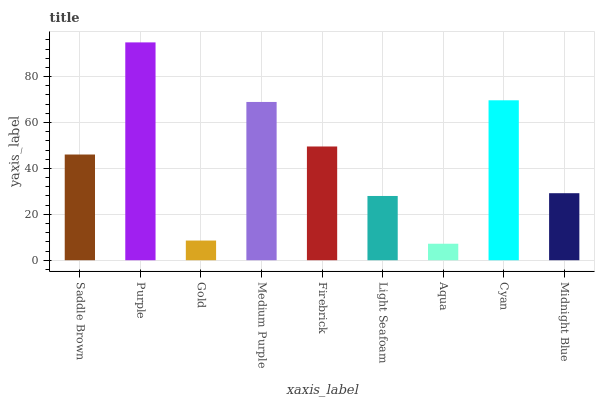Is Aqua the minimum?
Answer yes or no. Yes. Is Purple the maximum?
Answer yes or no. Yes. Is Gold the minimum?
Answer yes or no. No. Is Gold the maximum?
Answer yes or no. No. Is Purple greater than Gold?
Answer yes or no. Yes. Is Gold less than Purple?
Answer yes or no. Yes. Is Gold greater than Purple?
Answer yes or no. No. Is Purple less than Gold?
Answer yes or no. No. Is Saddle Brown the high median?
Answer yes or no. Yes. Is Saddle Brown the low median?
Answer yes or no. Yes. Is Medium Purple the high median?
Answer yes or no. No. Is Medium Purple the low median?
Answer yes or no. No. 